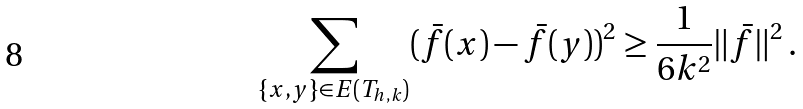<formula> <loc_0><loc_0><loc_500><loc_500>\sum _ { \{ x , y \} \in E ( T _ { h , k } ) } ( \bar { f } ( x ) - \bar { f } ( y ) ) ^ { 2 } \geq \frac { 1 } { 6 k ^ { 2 } } \| \bar { f } \| ^ { 2 } \, .</formula> 